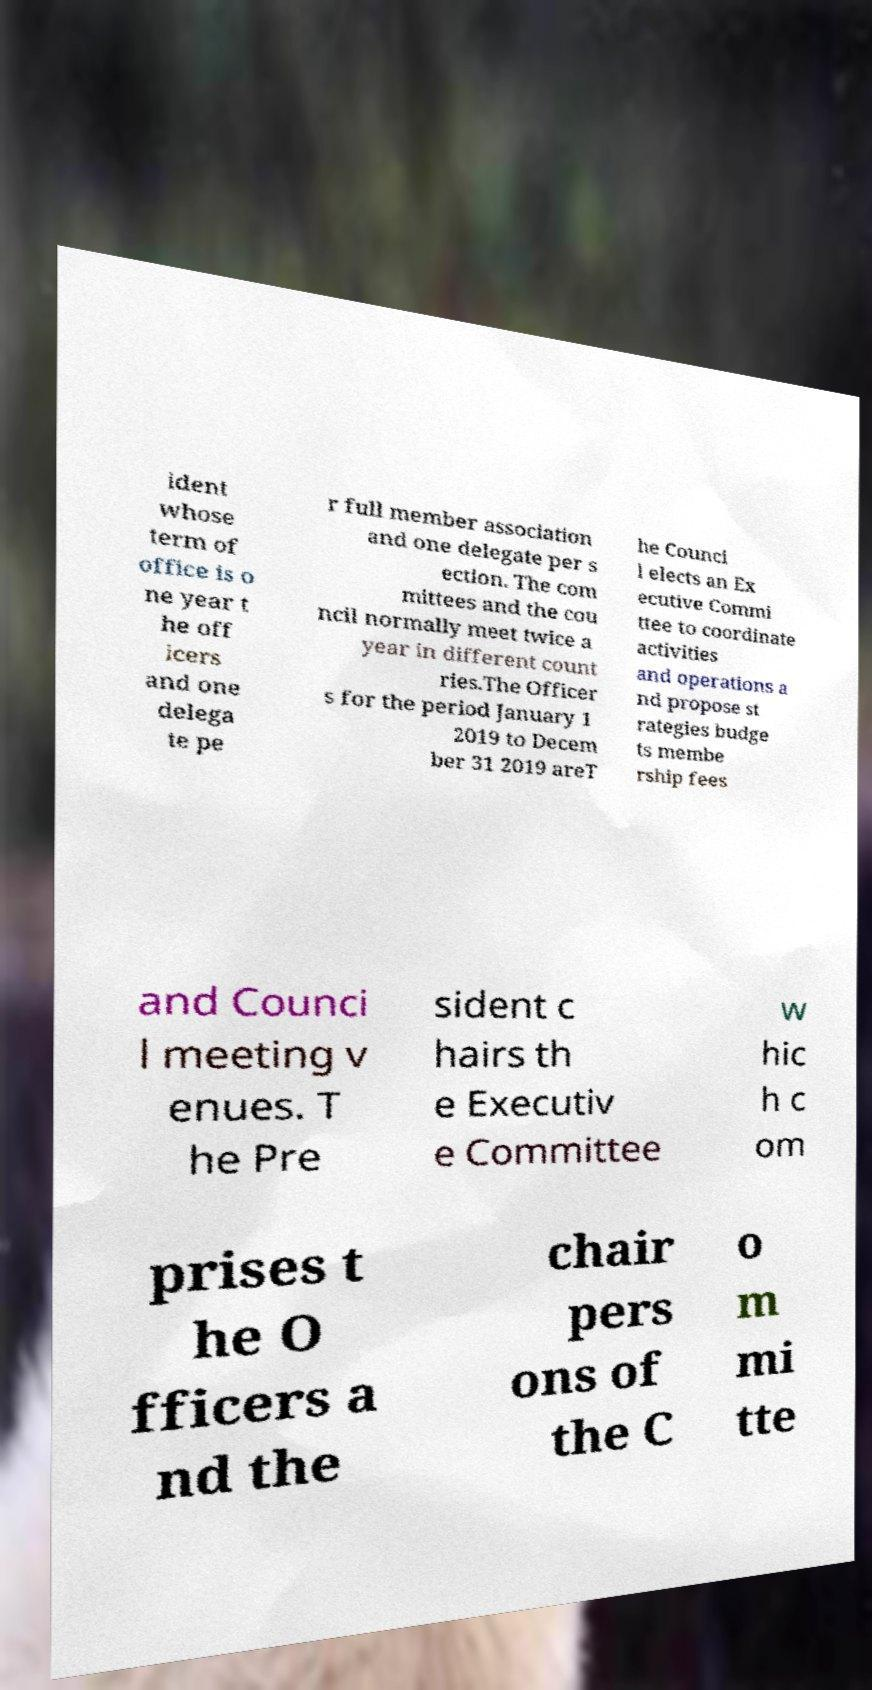For documentation purposes, I need the text within this image transcribed. Could you provide that? ident whose term of office is o ne year t he off icers and one delega te pe r full member association and one delegate per s ection. The com mittees and the cou ncil normally meet twice a year in different count ries.The Officer s for the period January 1 2019 to Decem ber 31 2019 areT he Counci l elects an Ex ecutive Commi ttee to coordinate activities and operations a nd propose st rategies budge ts membe rship fees and Counci l meeting v enues. T he Pre sident c hairs th e Executiv e Committee w hic h c om prises t he O fficers a nd the chair pers ons of the C o m mi tte 